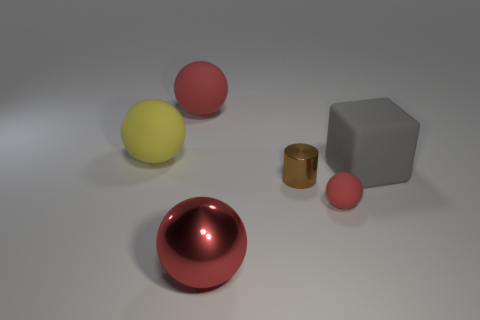How many red spheres must be subtracted to get 1 red spheres? 2 Subtract all yellow balls. How many balls are left? 3 Subtract all large red metal balls. How many balls are left? 3 Subtract all brown cylinders. How many red balls are left? 3 Add 1 small purple shiny objects. How many objects exist? 7 Subtract all gray balls. Subtract all yellow cylinders. How many balls are left? 4 Add 6 small red rubber objects. How many small red rubber objects are left? 7 Add 6 big red metallic objects. How many big red metallic objects exist? 7 Subtract 1 gray cubes. How many objects are left? 5 Subtract all spheres. How many objects are left? 2 